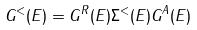<formula> <loc_0><loc_0><loc_500><loc_500>G ^ { < } ( E ) = G ^ { R } ( E ) \Sigma ^ { < } ( E ) G ^ { A } ( E )</formula> 